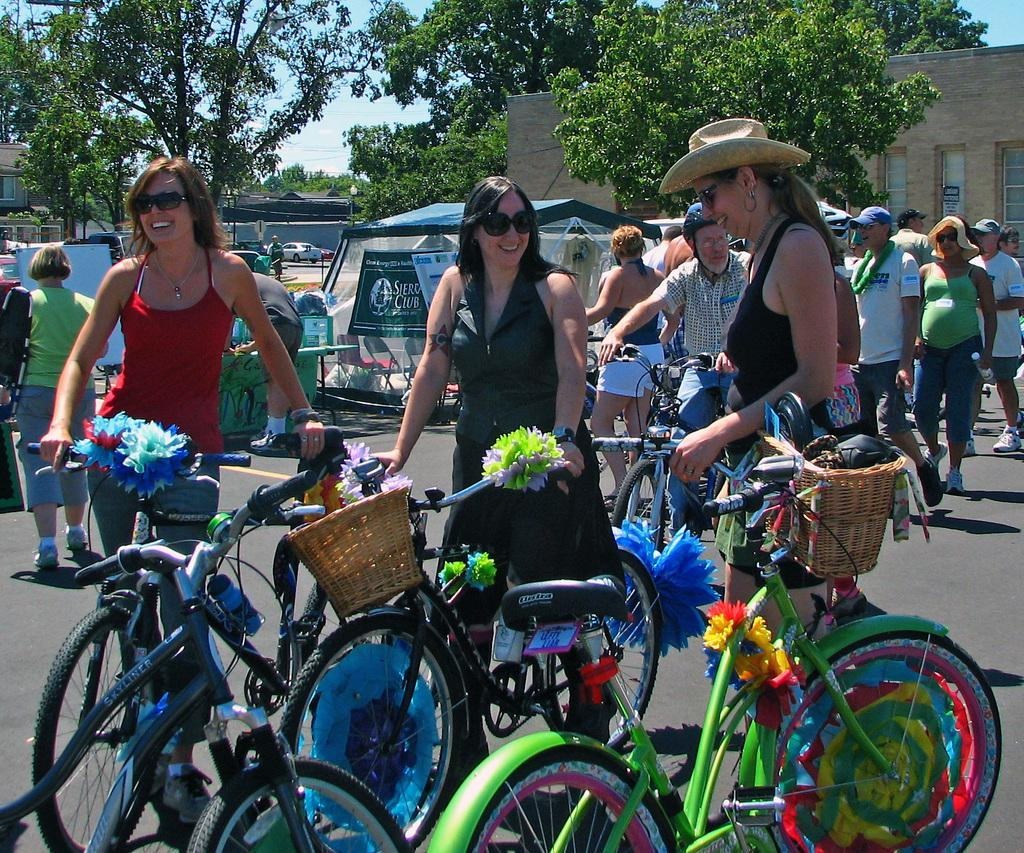How many women are in the image? There are three women in the image. What are the women doing in the image? The women are standing and holding bicycles. What can be seen in the background of the image? There are other people walking, a tent, vehicles, trees, buildings, and the sky visible in the background. How many frogs are sitting on the bicycles in the image? There are no frogs present in the image; it features three women standing and holding bicycles. What advice might the grandfather give to the women in the image? There is no grandfather present in the image, so it is not possible to determine what advice he might give. 